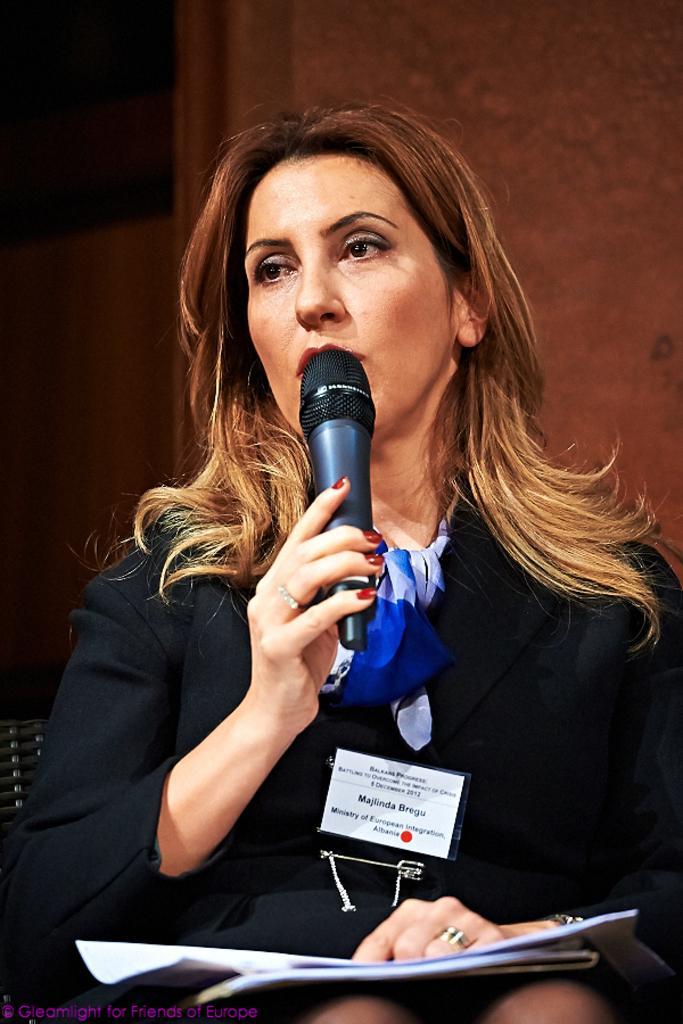Could you give a brief overview of what you see in this image? In the picture we can see a woman talking in a microphone and holding a papers, she is sitting with the black dress and brown hair, in the background we can see a curtain which is brown in color, and she is wearing a ID card. 